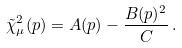Convert formula to latex. <formula><loc_0><loc_0><loc_500><loc_500>\tilde { \chi } _ { \mu } ^ { 2 } ( p ) = A ( p ) - \frac { B ( p ) ^ { 2 } } { C } \, .</formula> 